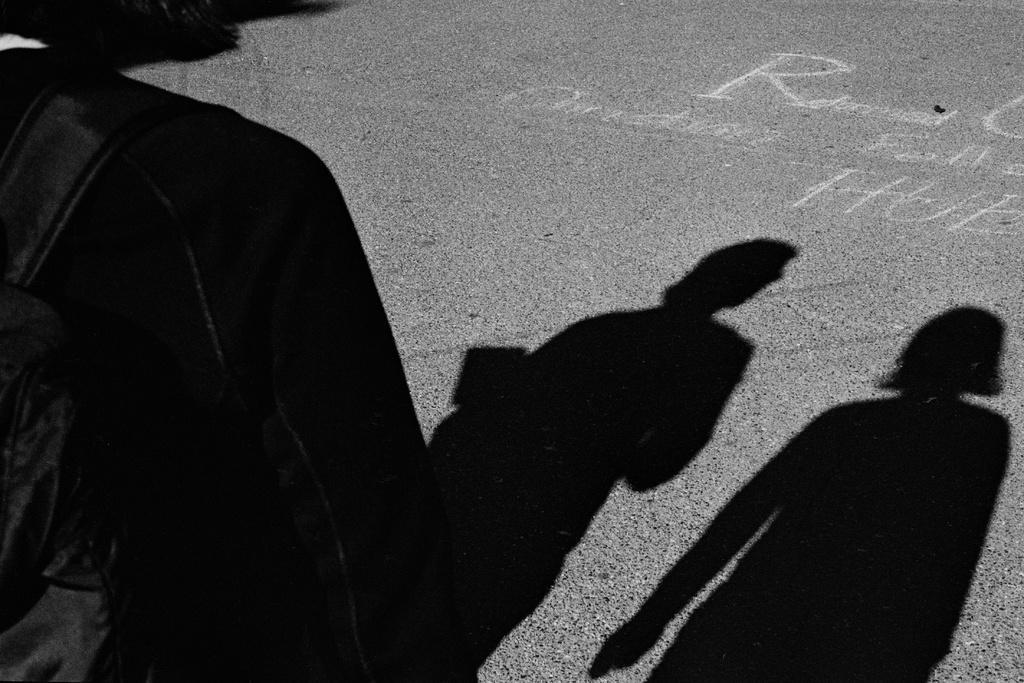Please provide a concise description of this image. In this image I can see a person shadow visible on the road I can see a black color jacket and I can see a backpack attached to the jacket. 